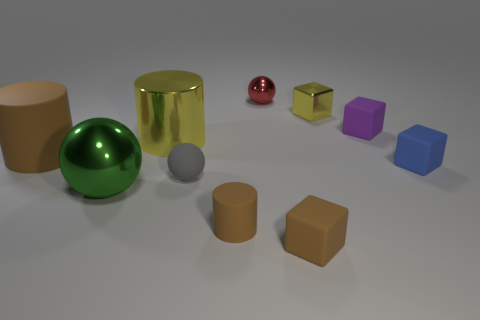Subtract all yellow metallic cylinders. How many cylinders are left? 2 Subtract 3 cylinders. How many cylinders are left? 0 Subtract all yellow spheres. Subtract all green cylinders. How many spheres are left? 3 Subtract all blue cylinders. How many gray spheres are left? 1 Subtract all rubber cylinders. Subtract all yellow objects. How many objects are left? 6 Add 5 balls. How many balls are left? 8 Add 9 big green metallic spheres. How many big green metallic spheres exist? 10 Subtract all yellow cylinders. How many cylinders are left? 2 Subtract 0 cyan cylinders. How many objects are left? 10 Subtract all cubes. How many objects are left? 6 